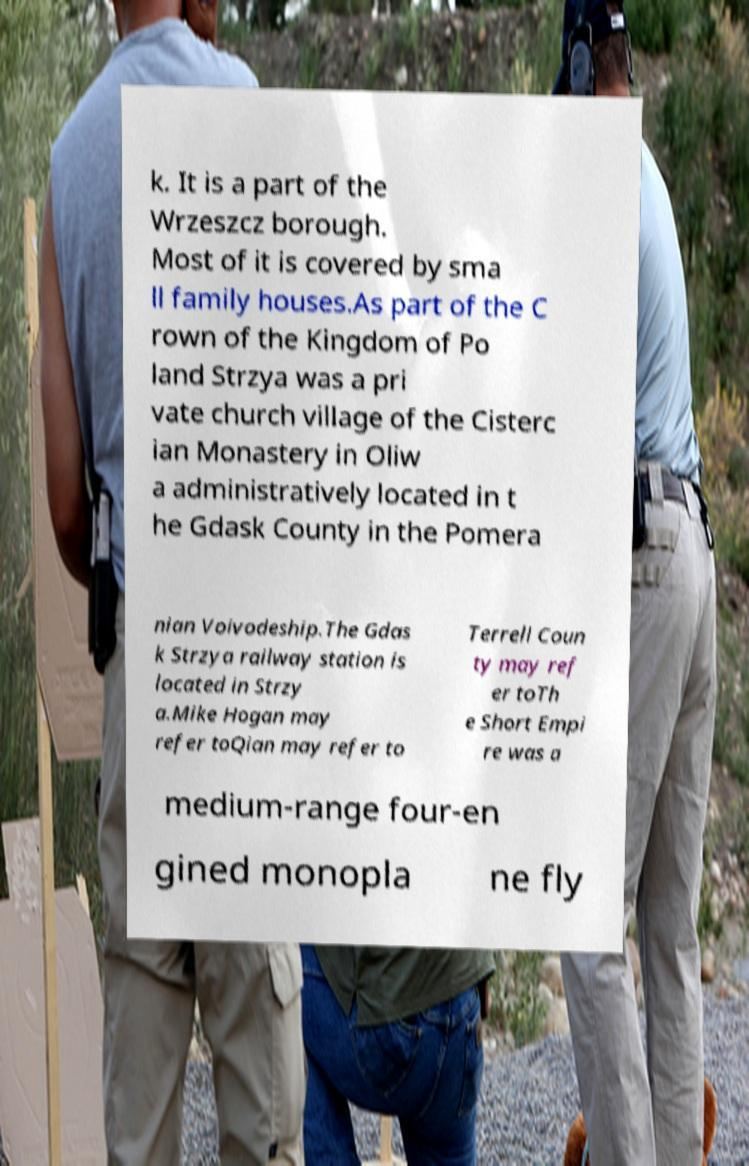Can you accurately transcribe the text from the provided image for me? k. It is a part of the Wrzeszcz borough. Most of it is covered by sma ll family houses.As part of the C rown of the Kingdom of Po land Strzya was a pri vate church village of the Cisterc ian Monastery in Oliw a administratively located in t he Gdask County in the Pomera nian Voivodeship.The Gdas k Strzya railway station is located in Strzy a.Mike Hogan may refer toQian may refer to Terrell Coun ty may ref er toTh e Short Empi re was a medium-range four-en gined monopla ne fly 